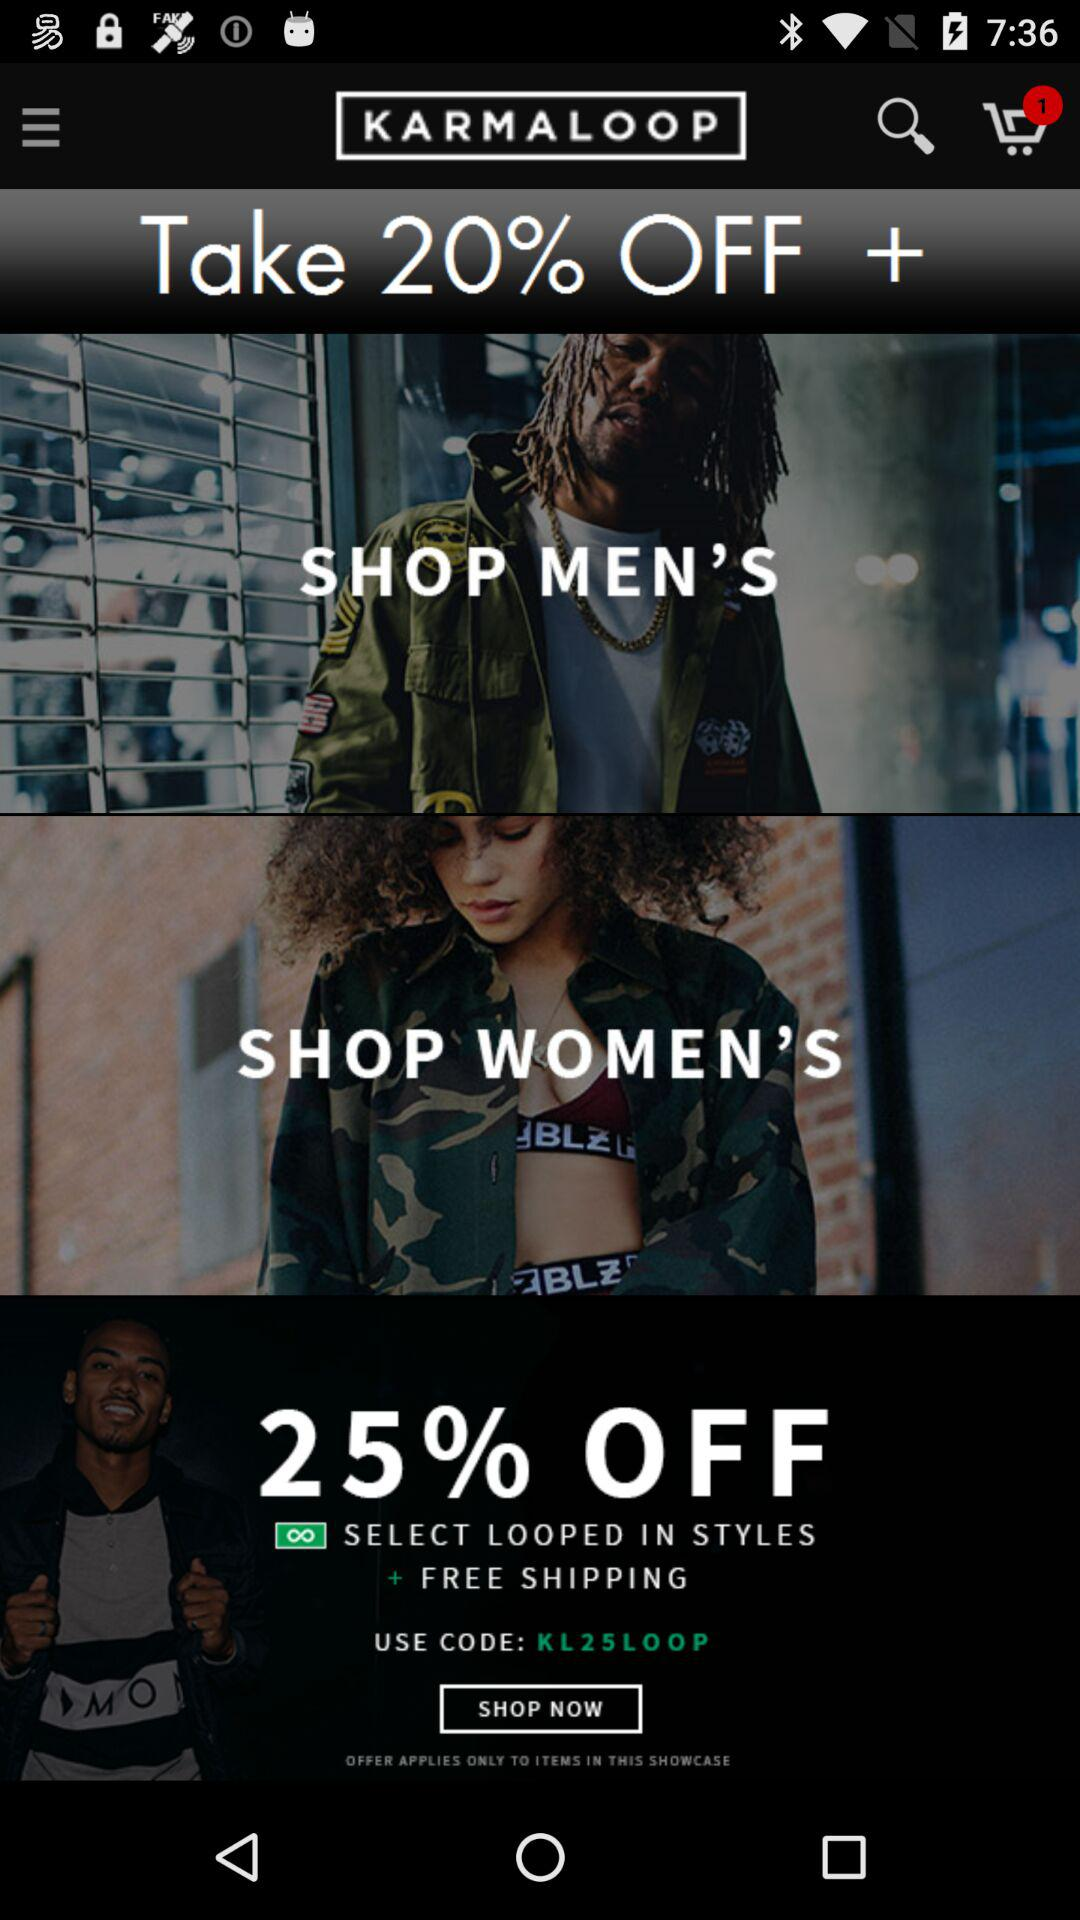What is the count of items in the cart? The count of items in the cart is 1. 